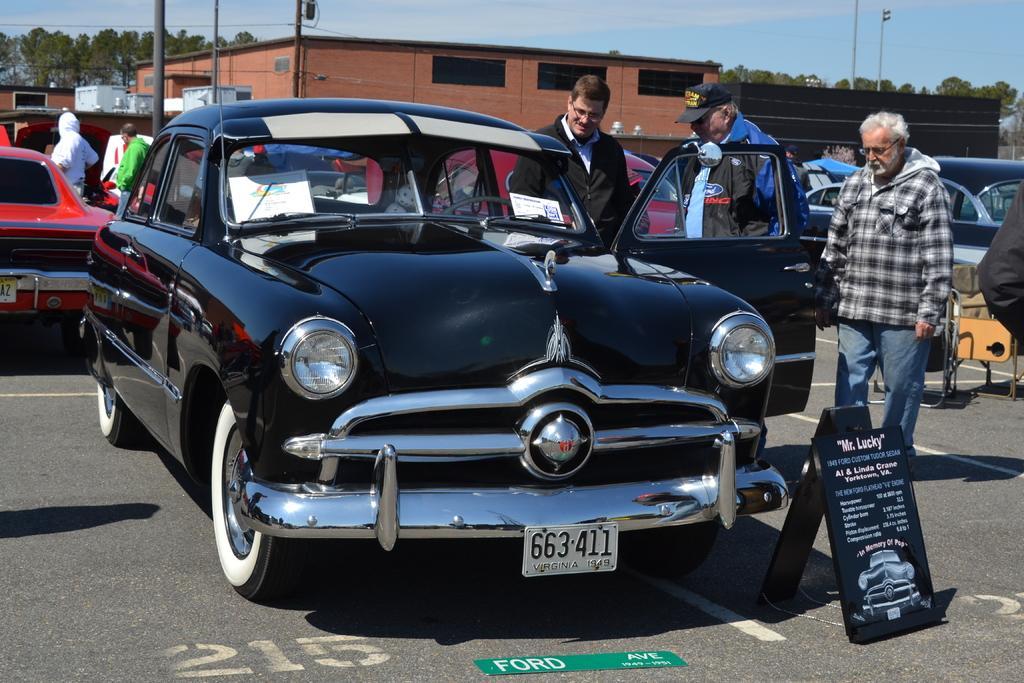Can you describe this image briefly? In this image we can see motor vehicles and person standing on the road, name boards, buildings, poles, cables, trees and sky with clouds. 